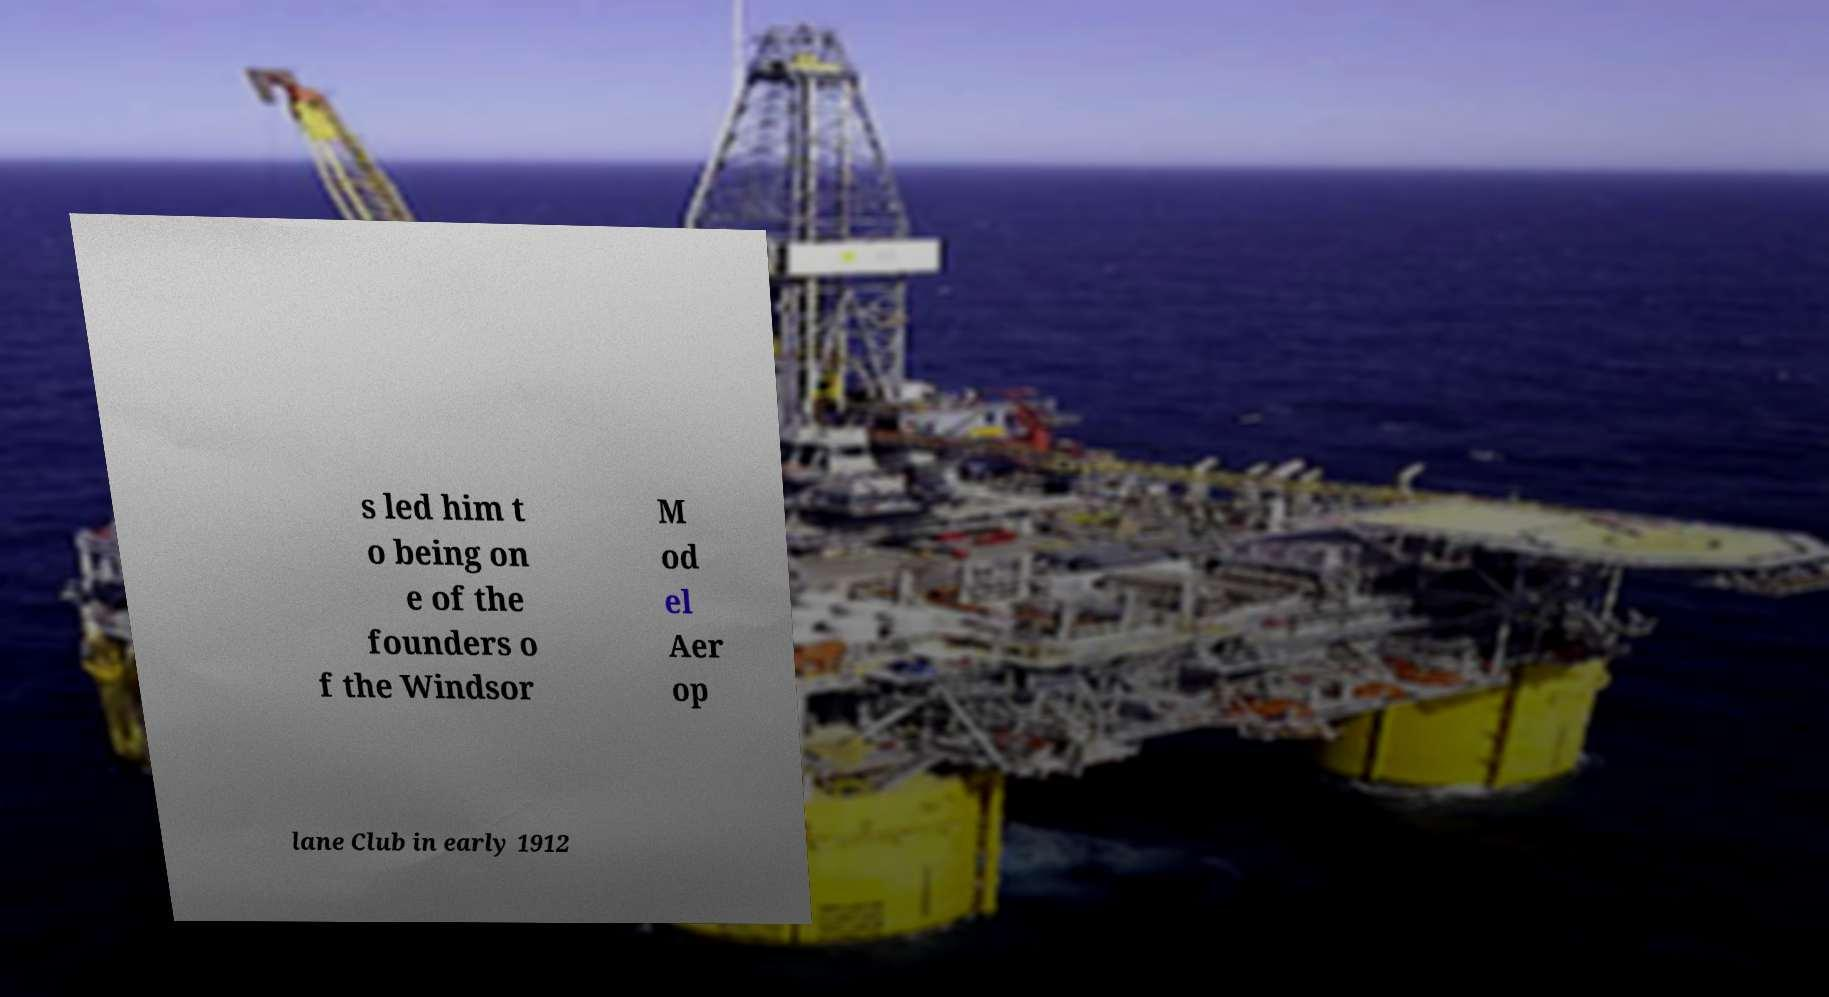For documentation purposes, I need the text within this image transcribed. Could you provide that? s led him t o being on e of the founders o f the Windsor M od el Aer op lane Club in early 1912 